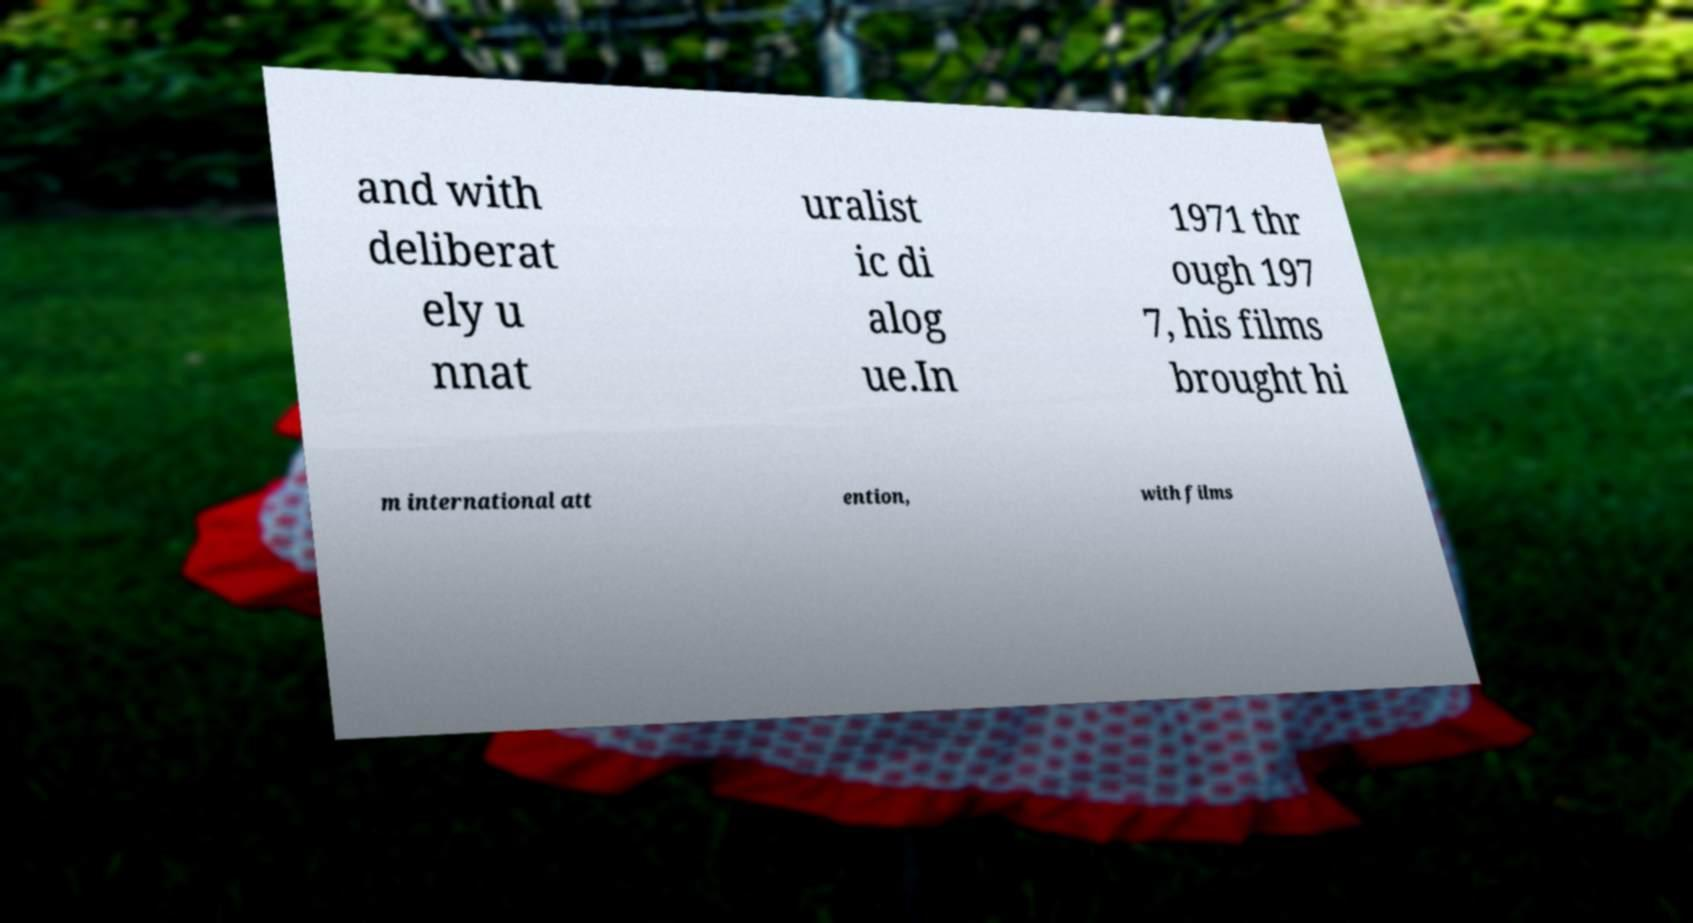Could you assist in decoding the text presented in this image and type it out clearly? and with deliberat ely u nnat uralist ic di alog ue.In 1971 thr ough 197 7, his films brought hi m international att ention, with films 